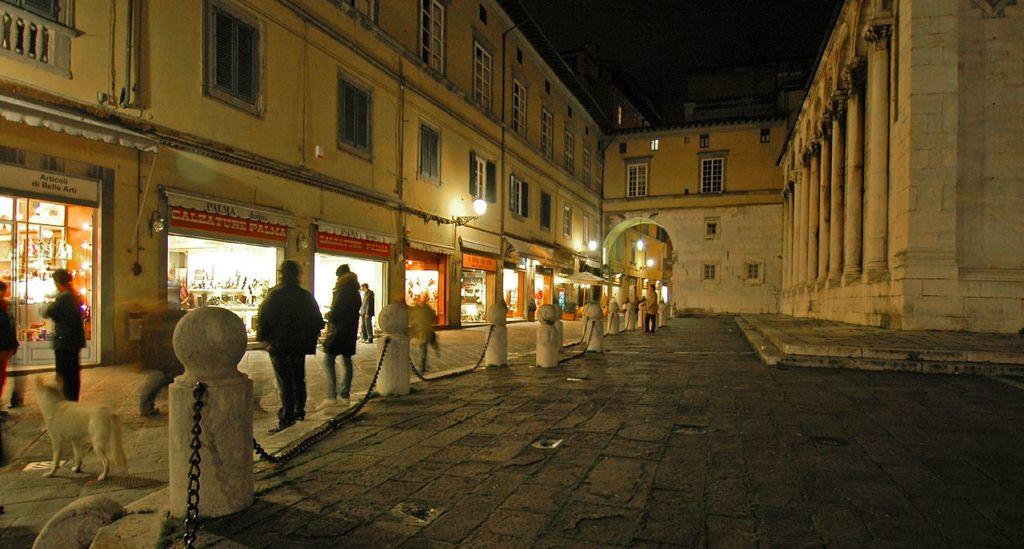What is written on the red sign of the second store?
Provide a short and direct response. Calzature palma. 